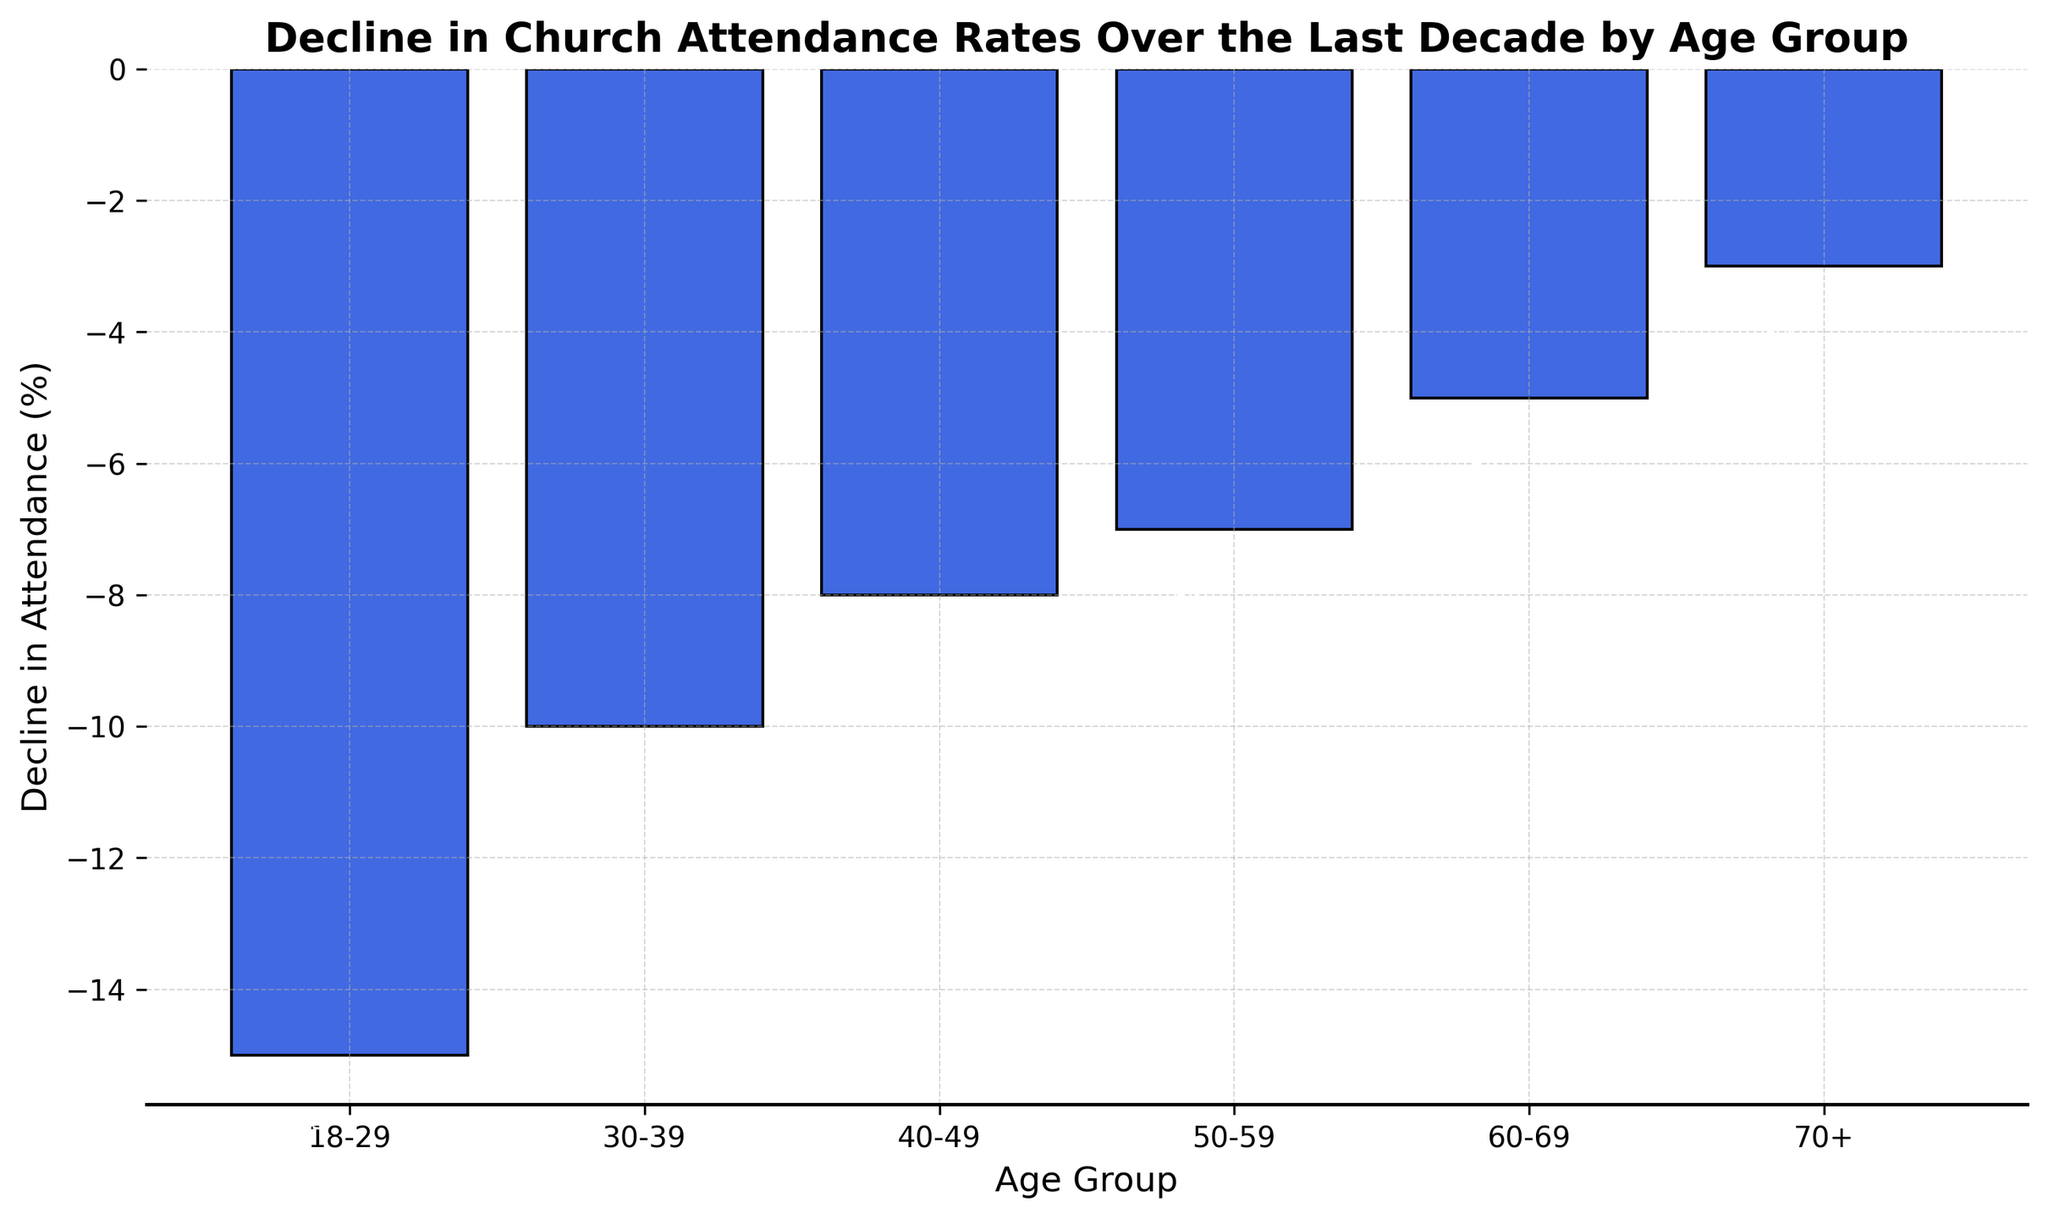What is the decline in attendance percentage for the 40-49 age group? The bar corresponding to the 40-49 age group shows a decline in attendance of -8%.
Answer: -8% Which age group experienced the smallest decline in church attendance? By comparing the heights of the bars, the age group 70+ has the smallest decline at -3%.
Answer: 70+ What's the difference in the decline between the 18-29 age group and the 60-69 age group? The decline for 18-29 is -15%, and for 60-69 is -5%. The difference is -15% - (-5%) = -10%.
Answer: -10% Which age group saw a greater decline in attendance, the 30-39 age group or the 50-59 age group? By comparing the bar heights, the 30-39 age group had a decline of -10% while the 50-59 age group had a decline of -7%.
Answer: 30-39 What is the average decline in attendance across all age groups? Sum up the declines (-15 + -10 + -8 + -7 + -5 + -3) = -48. There are 6 age groups, so average decline = -48 / 6 = -8%.
Answer: -8% Is the decline in attendance for the 30-39 age group more than twice the decline for the 70+ age group? The decline for the 30-39 age group is -10% and for 70+ is -3%. Twice the decline of 70+ is 2 * -3% = -6%. Since -10% is more than -6%, the decline is indeed more than twice.
Answer: Yes Which age group has a decline closest to the overall average decline? The overall average decline is -8%. The 50-59 age group has a decline of -7%, which is closest to -8%.
Answer: 50-59 Arrange the age groups in order of increasing decline in church attendance. The declines in increasing order are: 70+ (-3%), 60-69 (-5%), 50-59 (-7%), 40-49 (-8%), 30-39 (-10%), 18-29 (-15%).
Answer: 70+, 60-69, 50-59, 40-49, 30-39, 18-29 What is the median decline in attendance among all the age groups? Arrange the declines: -15, -10, -8, -7, -5, -3. The median decline is the middle value between the third and fourth values: (-8 + -7) / 2 = -7.5%.
Answer: -7.5% Which age group has a decline exactly half that of the 18-29 age group? The 18-29 age group has a decline of -15%. Half of -15% is -7.5%. There is no age group with exactly -7.5%; however, the decline for the 50-59 age group is -7%, which is close but not exact.
Answer: None 